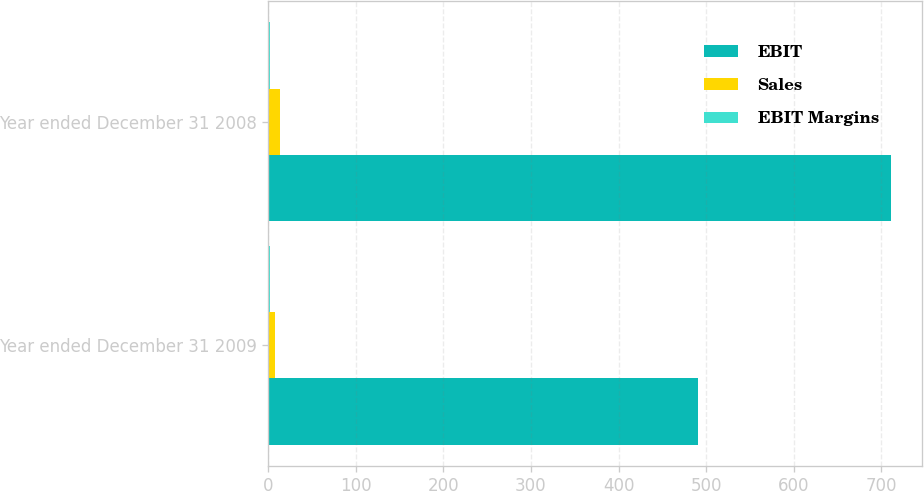Convert chart to OTSL. <chart><loc_0><loc_0><loc_500><loc_500><stacked_bar_chart><ecel><fcel>Year ended December 31 2009<fcel>Year ended December 31 2008<nl><fcel>EBIT<fcel>491<fcel>711<nl><fcel>Sales<fcel>8<fcel>14<nl><fcel>EBIT Margins<fcel>1.6<fcel>2<nl></chart> 